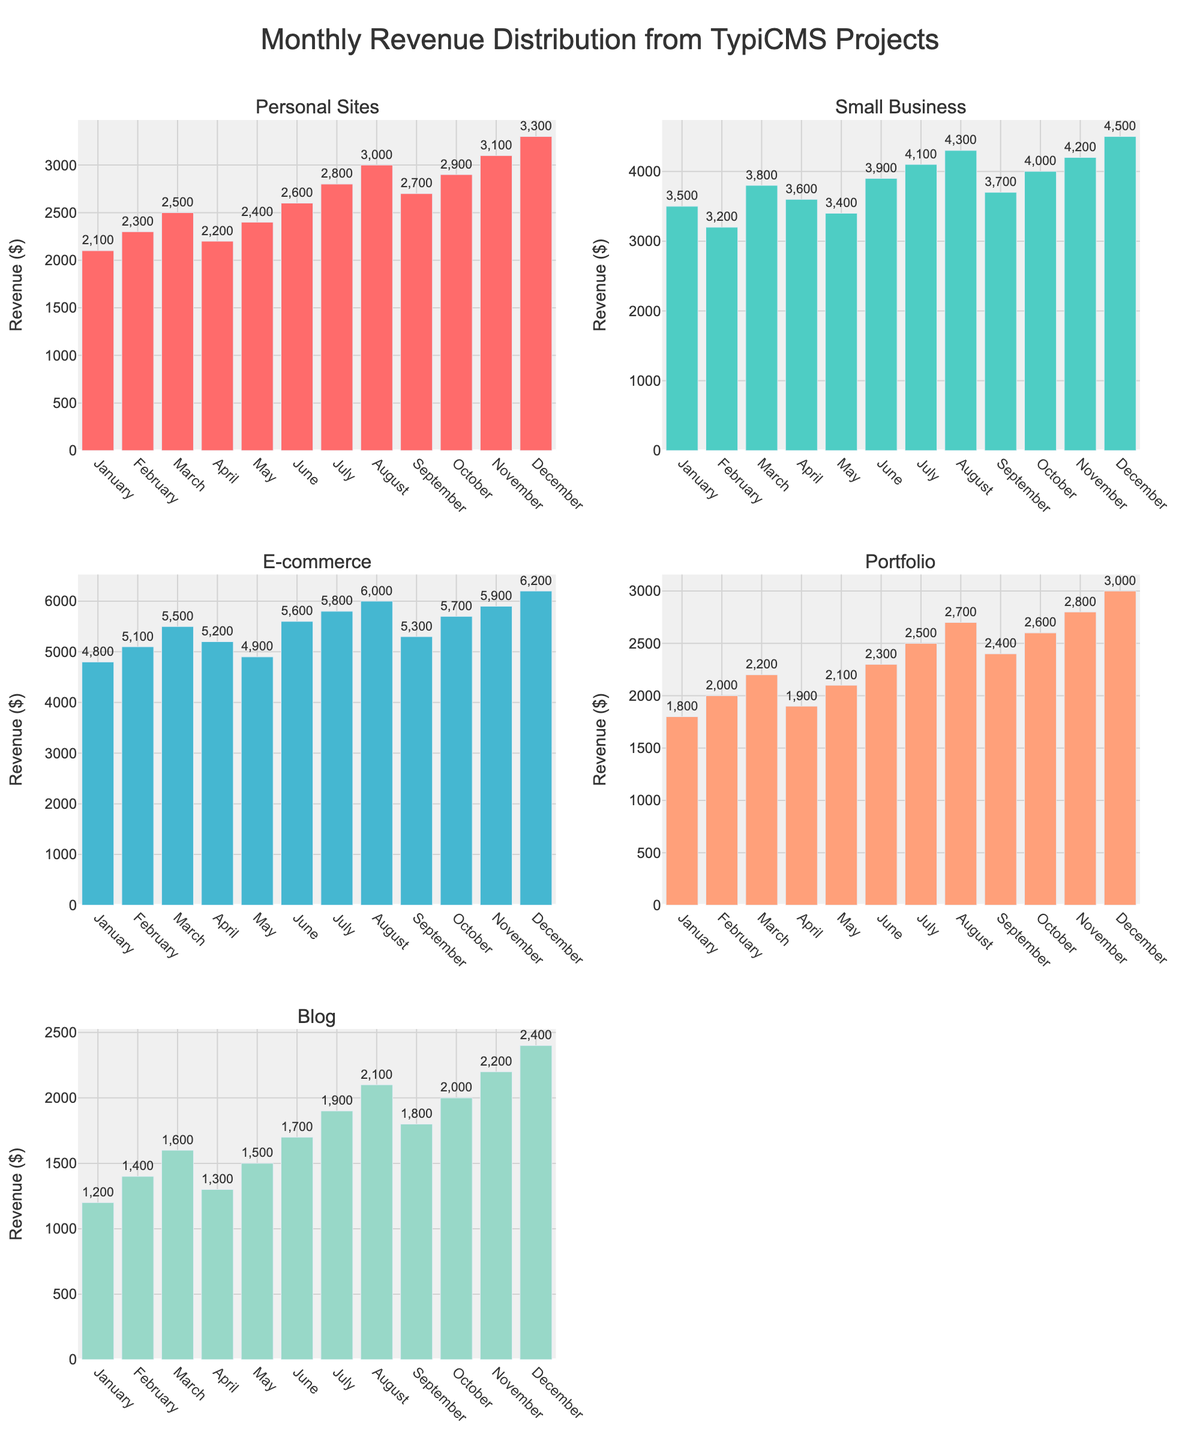How many categories of projects are depicted in the figure? The number of subplot titles indicates the number of categories. In this figure, there are 5 subplots, each representing a category of projects.
Answer: 5 What is the average monthly revenue for E-commerce projects? Add all monthly revenues for E-commerce projects and divide by 12. The sum is 4800 + 5100 + 5500 + 5200 + 4900 + 5600 + 5800 + 6000 + 5300 + 5700 + 5900 + 6200 = 66100, so the average is 66100/12 = 5508.33
Answer: 5508.33 Which month recorded the highest revenue for Portfolio projects? By examining the "Portfolio" subplot, December shows the highest bar, indicating the highest revenue.
Answer: December Compare the revenues of Personal Sites and Blog projects in July. Which one is higher and by how much? The revenue for Personal Sites in July is 2800, and for Blog projects, it is 1900. Subtract Blog revenue from Personal Sites revenue: 2800 - 1900 = 900.
Answer: Personal Sites by 900 What is the median monthly revenue for Small Business projects? Order the monthly revenues for Small Business: 3200, 3400, 3500, 3600, 3700, 3800, 3900, 4000, 4100, 4200, 4300, 4500. The median is the average of the 6th and 7th values: (3800+3900)/2 = 3850
Answer: 3850 What is the total combined revenue for E-commerce projects over the year? Summing all the monthly revenues for E-commerce projects: 4800 + 5100 + 5500 + 5200 + 4900 + 5600 + 5800 + 6000 + 5300 + 5700 + 5900 + 6200 = 66100
Answer: 66100 Which project category experienced the least revenue fluctuation over the year? By comparing the range (max - min) of each category's revenue, Small Business projects have the smallest range: 4500 - 3200 = 1300. This is less than the ranges for the other categories.
Answer: Small Business Between August to October, which month had the highest total revenue combining all project categories? Sum the monthly revenues for all categories for each month from August to October:
- August: 3000 + 4300 + 6000 + 2700 + 2100 = 18100
- September: 2700 + 3700 + 5300 + 2400 + 1800 = 15900
- October: 2900 + 4000 + 5700 + 2600 + 2000 = 17200
August has the highest total revenue.
Answer: August In which month did Blog projects experience the highest revenue growth compared to the previous month? Compare the difference in revenue for Blog projects month-to-month:
- January to February: 200
- February to March: 200
- March to April: -300
- April to May: 200
- May to June: 200
- June to July: 200
- July to August: 200
- August to September: -300
- September to October: 200
- October to November: 200
- November to December: 200
Consistently, the highest growth is 200, which occurs in several months.
Answer: February, March, May, June, July, August, October, November, December 